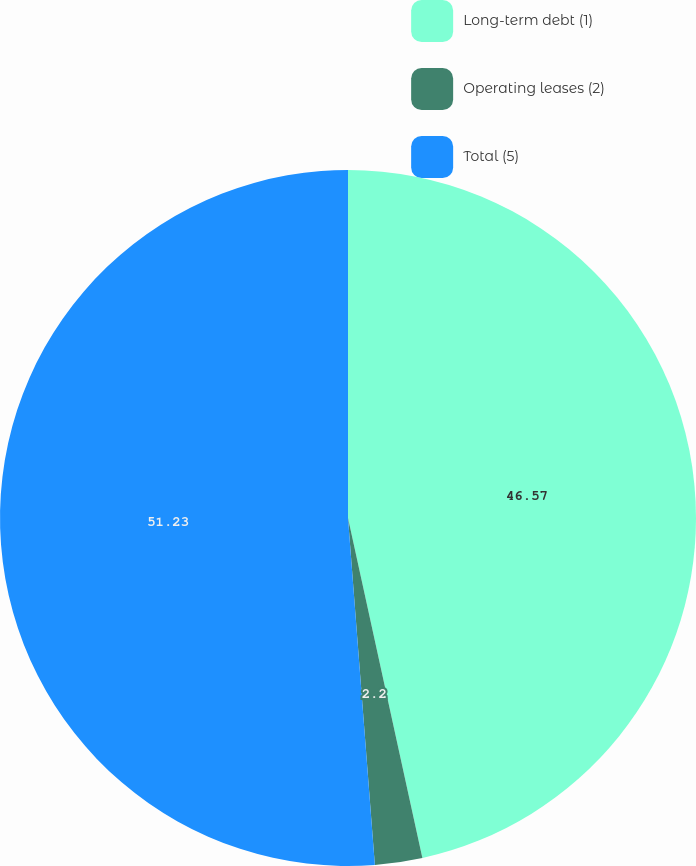Convert chart. <chart><loc_0><loc_0><loc_500><loc_500><pie_chart><fcel>Long-term debt (1)<fcel>Operating leases (2)<fcel>Total (5)<nl><fcel>46.57%<fcel>2.2%<fcel>51.23%<nl></chart> 